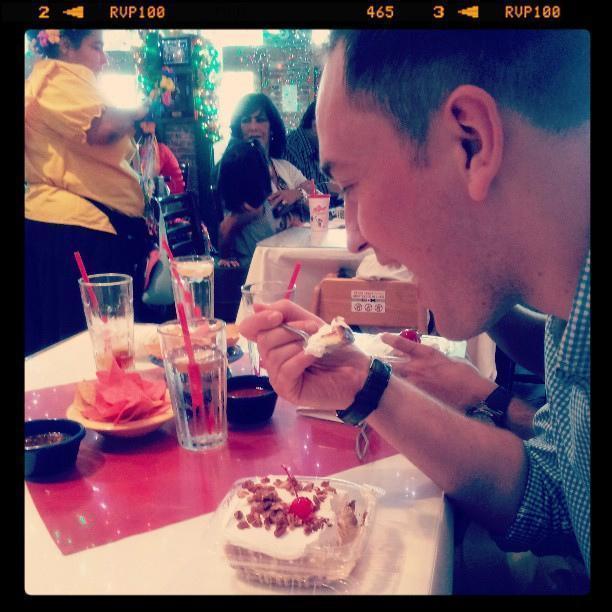What is the red object in the food the man is eating?
Answer the question by selecting the correct answer among the 4 following choices.
Options: Apple, pepper, cherry, tomato. Cherry. 